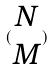<formula> <loc_0><loc_0><loc_500><loc_500>( \begin{matrix} N \\ M \end{matrix} )</formula> 